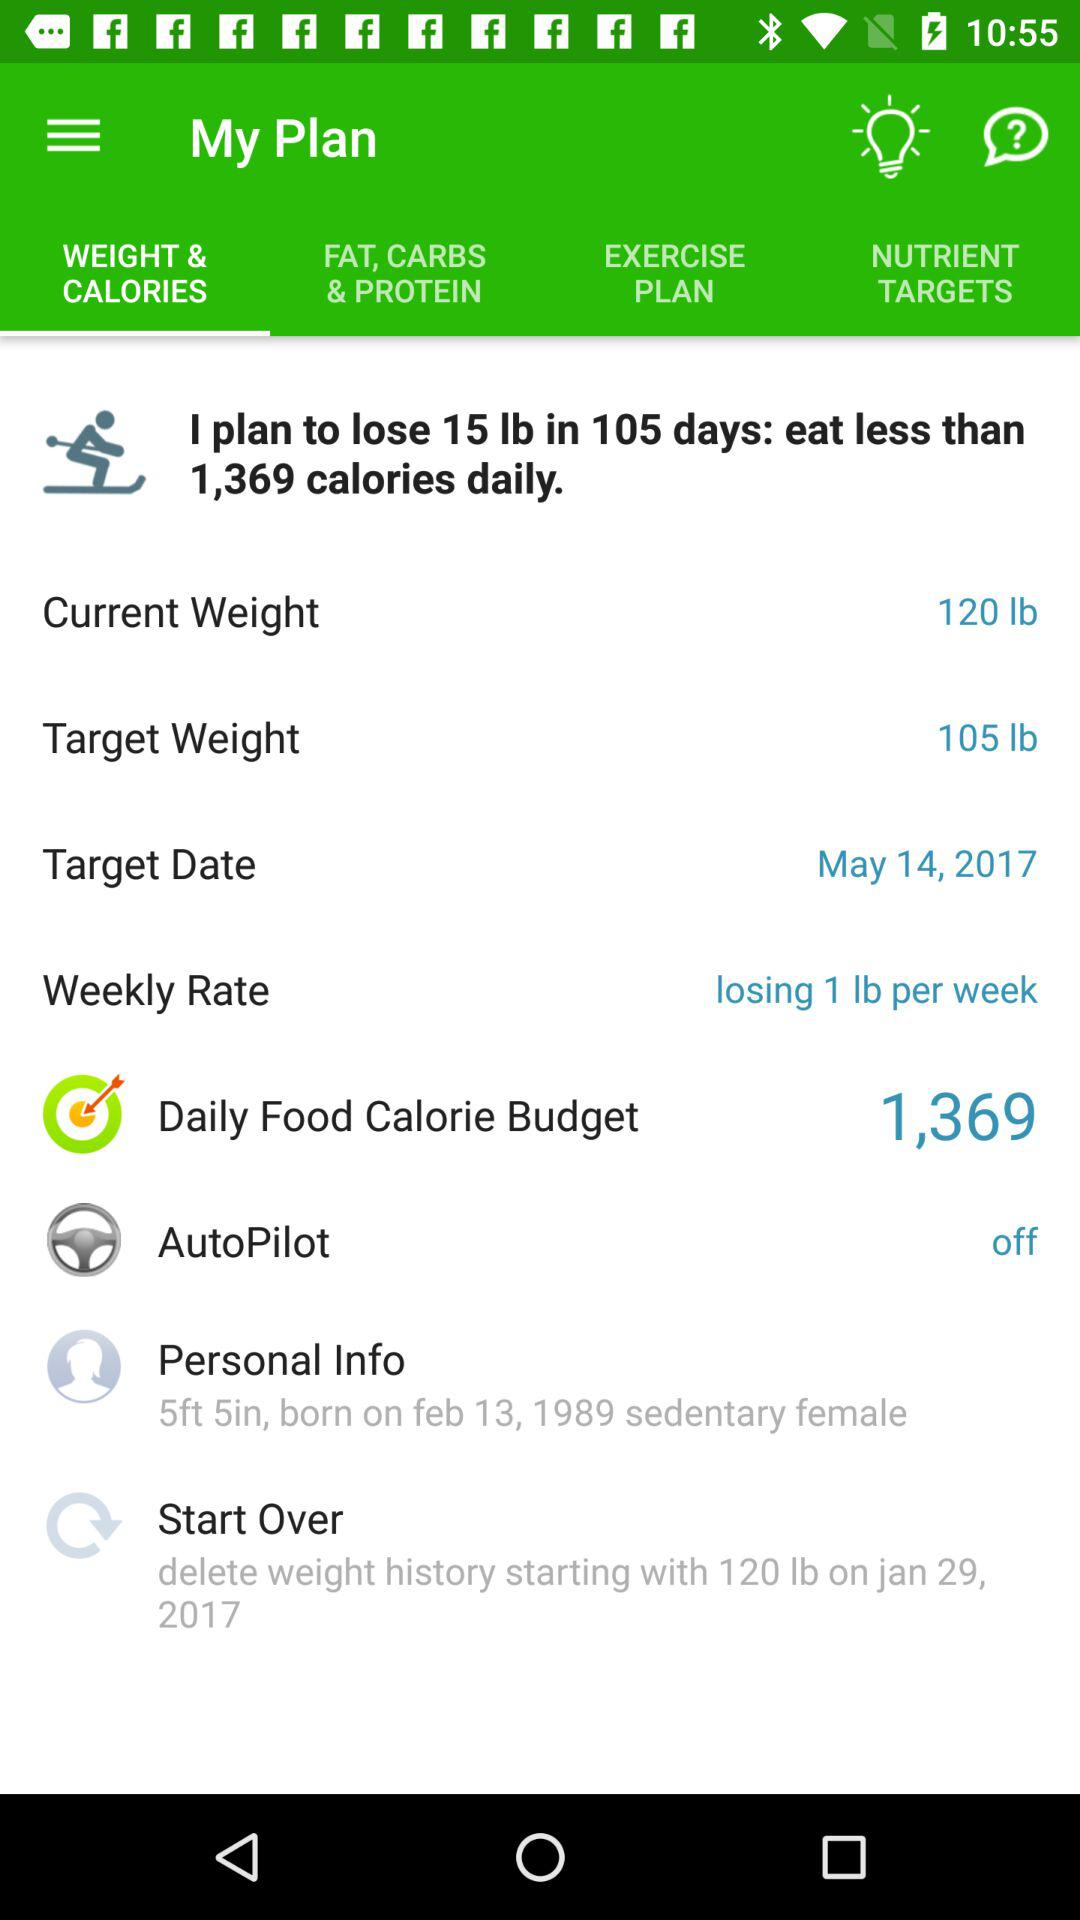What is "Daily Food Calorie Budget"? The "Daily Food Calorie Budget" is 1,369. 